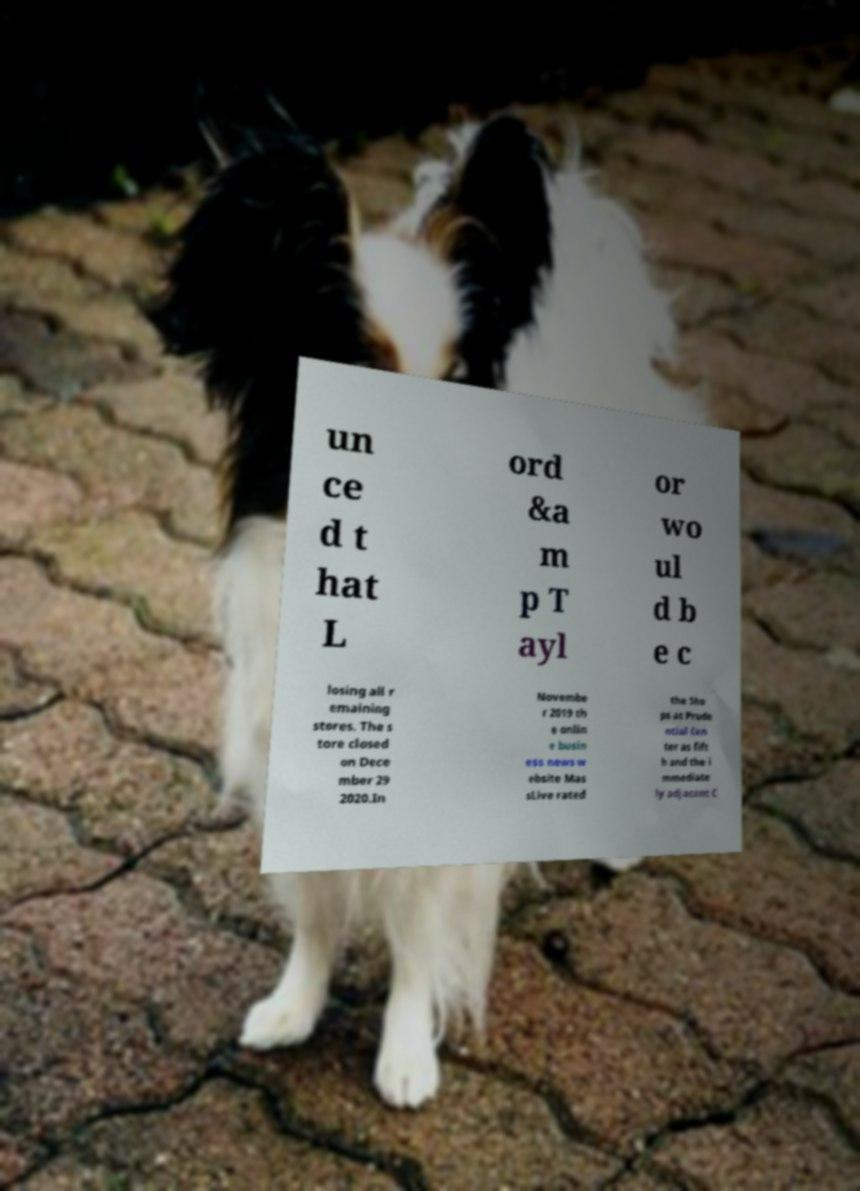There's text embedded in this image that I need extracted. Can you transcribe it verbatim? un ce d t hat L ord &a m p T ayl or wo ul d b e c losing all r emaining stores. The s tore closed on Dece mber 29 2020.In Novembe r 2019 th e onlin e busin ess news w ebsite Mas sLive rated the Sho ps at Prude ntial Cen ter as fift h and the i mmediate ly adjacent C 